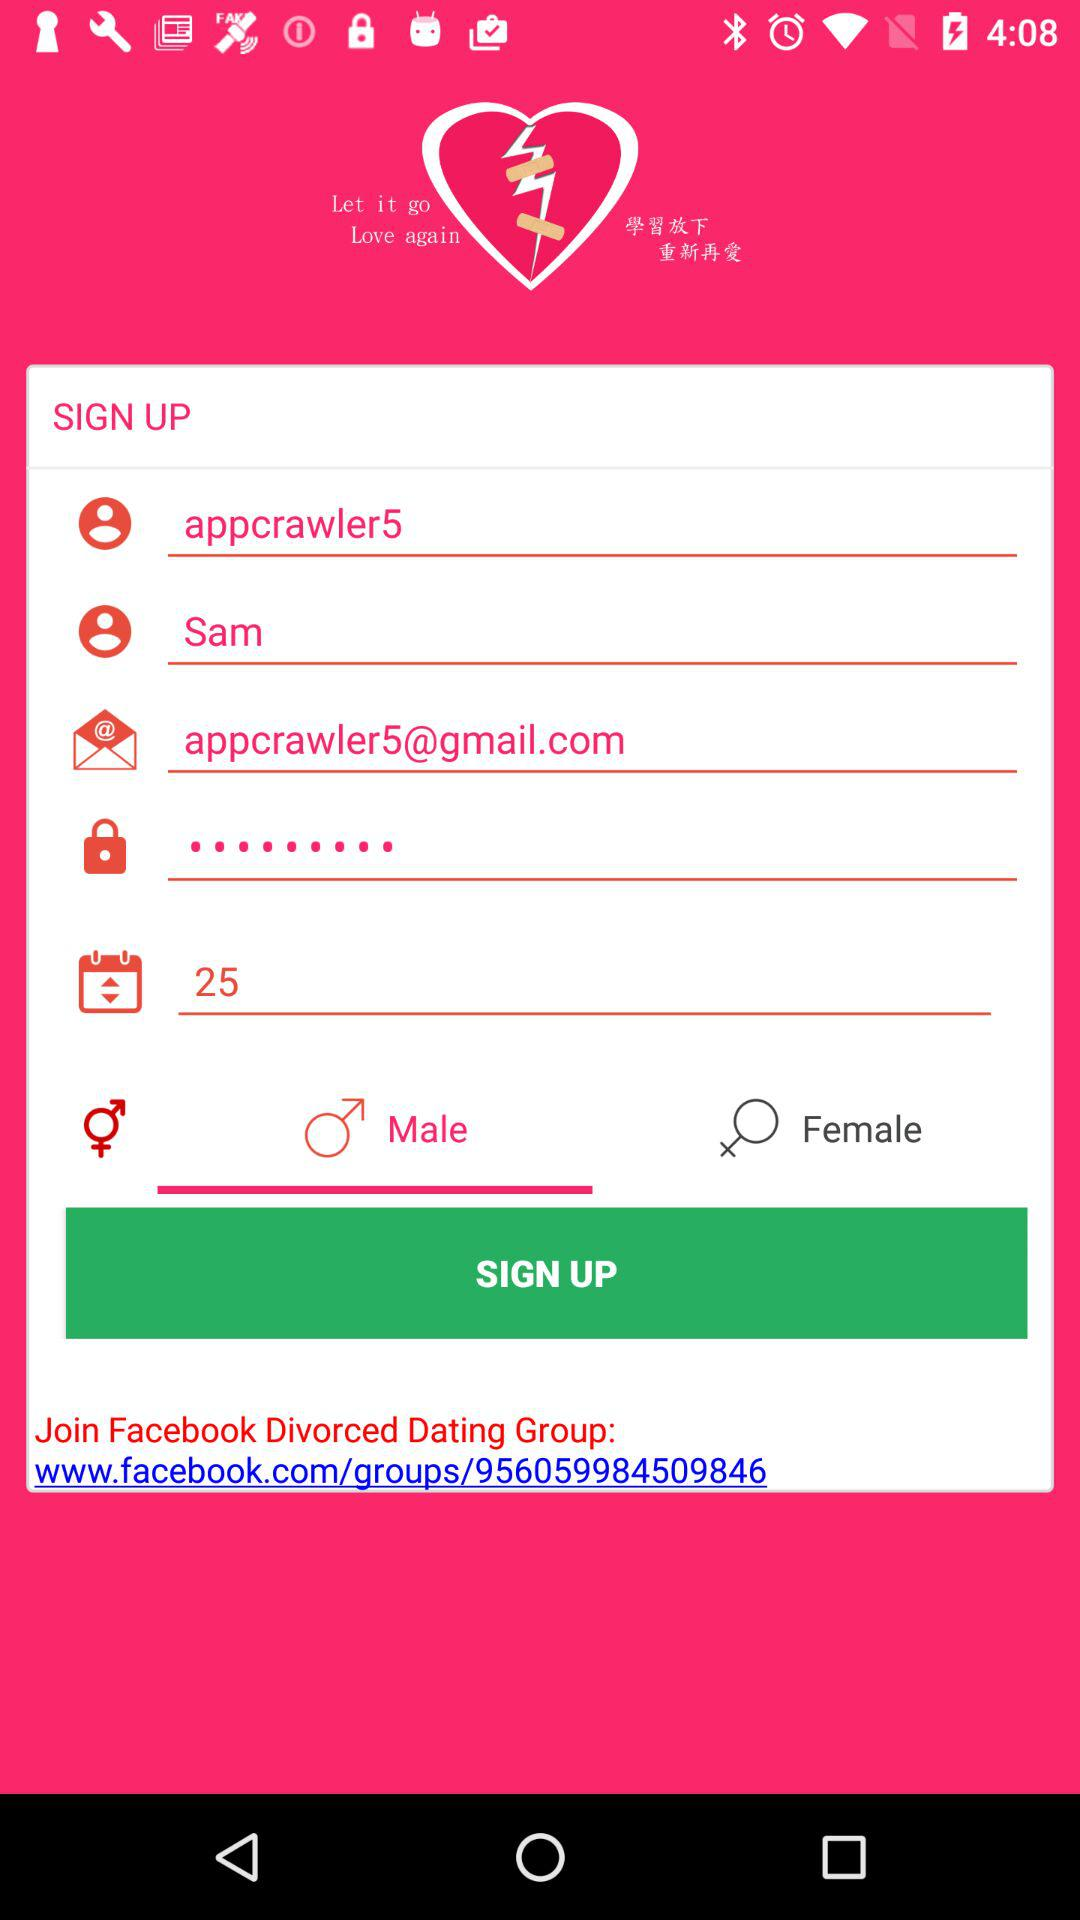What is the age? The age is 25 years old. 